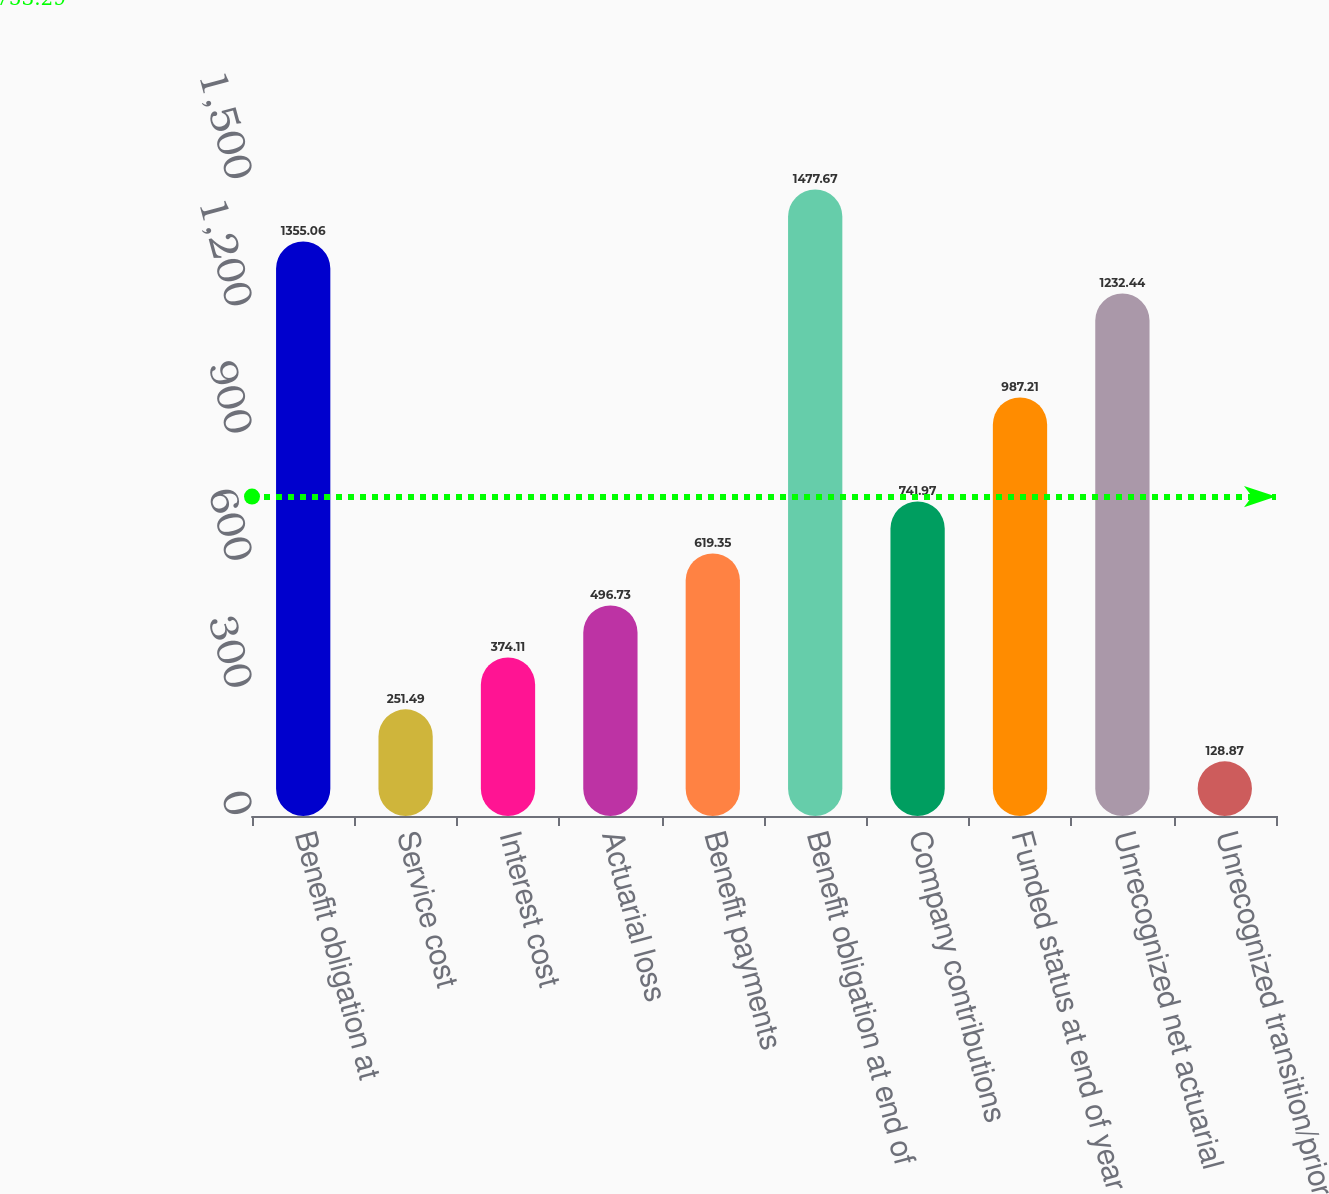<chart> <loc_0><loc_0><loc_500><loc_500><bar_chart><fcel>Benefit obligation at<fcel>Service cost<fcel>Interest cost<fcel>Actuarial loss<fcel>Benefit payments<fcel>Benefit obligation at end of<fcel>Company contributions<fcel>Funded status at end of year<fcel>Unrecognized net actuarial<fcel>Unrecognized transition/prior<nl><fcel>1355.06<fcel>251.49<fcel>374.11<fcel>496.73<fcel>619.35<fcel>1477.67<fcel>741.97<fcel>987.21<fcel>1232.44<fcel>128.87<nl></chart> 